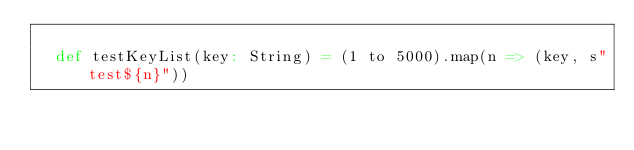Convert code to text. <code><loc_0><loc_0><loc_500><loc_500><_Scala_>
  def testKeyList(key: String) = (1 to 5000).map(n => (key, s"test${n}"))
</code> 